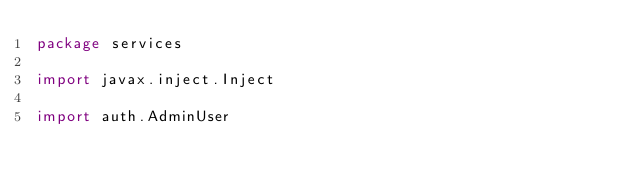Convert code to text. <code><loc_0><loc_0><loc_500><loc_500><_Scala_>package services

import javax.inject.Inject

import auth.AdminUser</code> 